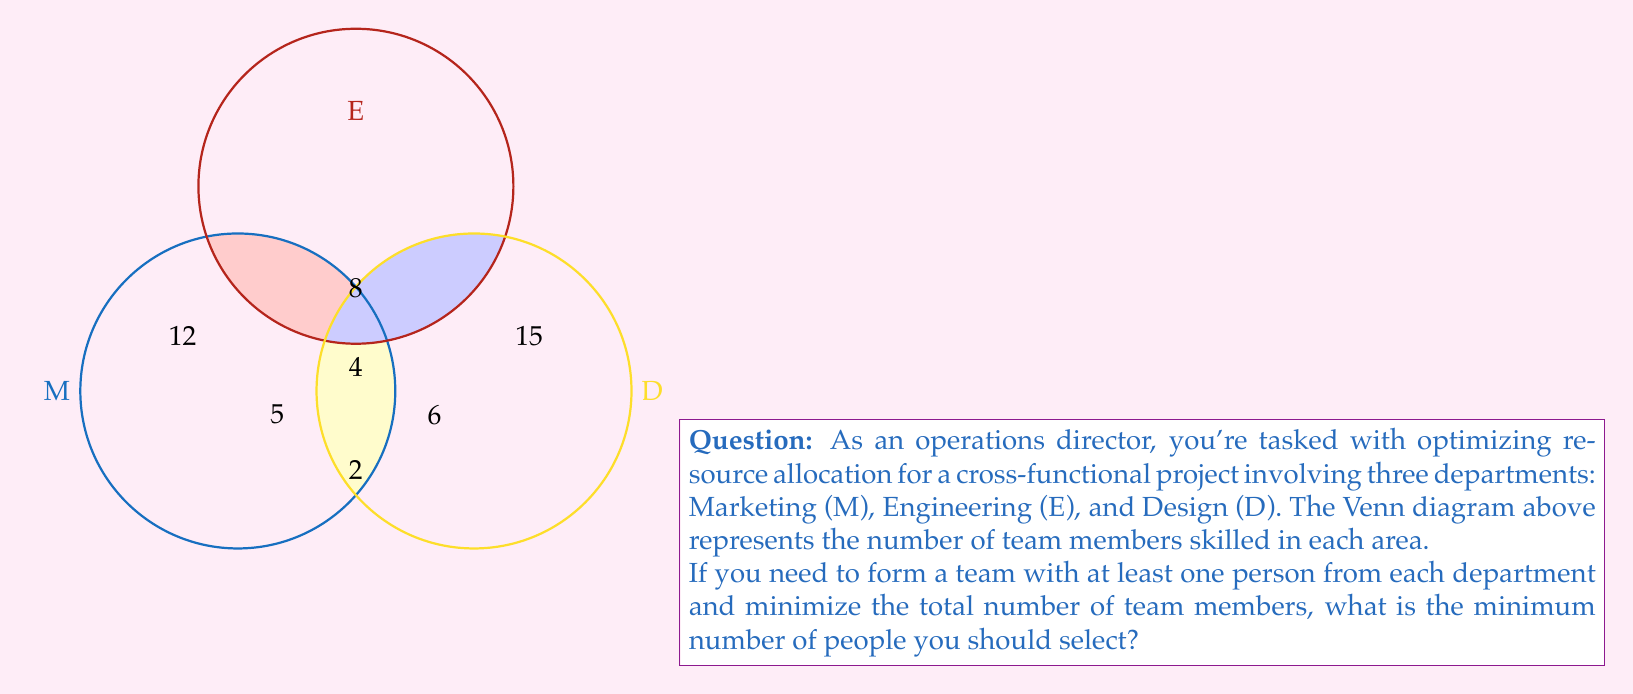Can you solve this math problem? Let's approach this step-by-step:

1) First, we need to understand what the Venn diagram represents:
   - The numbers in each region represent team members with skills in those specific areas.
   - The overlapping regions represent team members with multiple skills.

2) To minimize the team size while ensuring at least one person from each department, we should prioritize selecting people from the overlapping regions.

3) The optimal selection strategy would be:
   a) Select one person from the center region (4) who has skills in all three areas (M ∩ E ∩ D).
   b) If this person doesn't exist or we've exhausted this option, we move to the two-skill intersections.

4) In this case, we have a person in the center region, so selecting this one person satisfies our requirement of having at least one person from each department.

5) Therefore, the minimum number of people to select is 1.

6) Mathematically, we can express this as:

   $$\min(|M \cap E \cap D|, |M \cap E| + |E \cap D| + |M \cap D| - 2|M \cap E \cap D|) = \min(4, 8 + 6 + 5 - 2(4)) = \min(4, 11) = 4$$

   However, we only need to select one person from this group of 4 to meet our criteria.
Answer: 1 